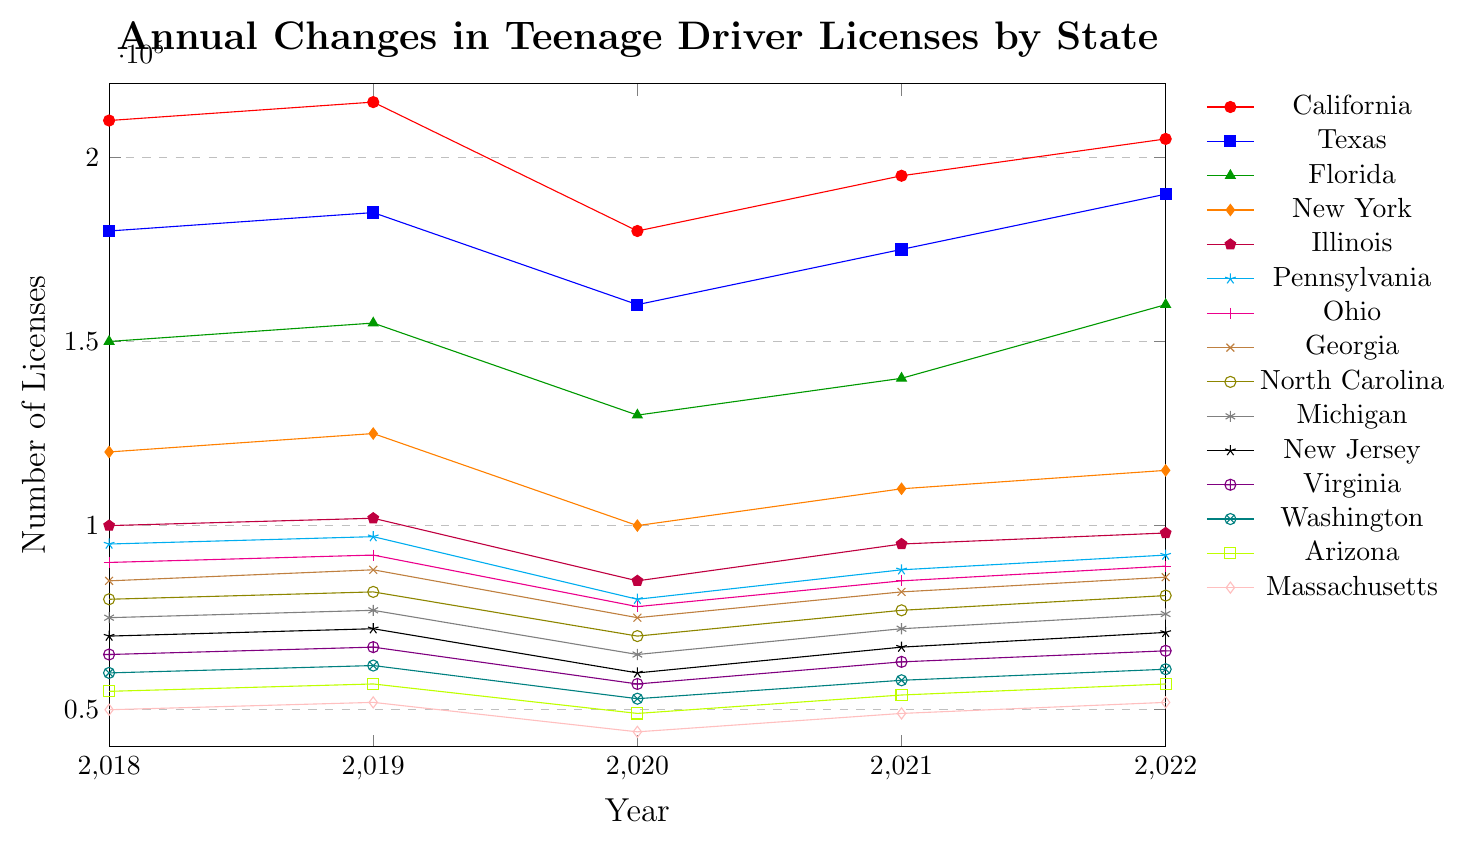Which state had the most teenage drivers obtaining licenses in 2020? The chart shows the number of teenage drivers obtaining licenses for each state across different years. For 2020, the highest value is for California with 180,000 licenses.
Answer: California Which state experienced the largest decrease in the number of teenage drivers obtaining licenses from 2019 to 2020? To find the largest decrease, calculate the difference between 2019 and 2020 numbers for each state. California had a decrease from 215,000 to 180,000, which is the largest drop of 35,000.
Answer: California By how much did the number of teenage drivers obtaining licenses in Georgia change from 2018 to 2022? Look at Georgia's values for 2018 (85,000) and 2022 (86,000), then subtract the 2018 value from the 2022 value: 86,000 - 85,000 = 1,000.
Answer: 1,000 Which state had the least fluctuations in teenage driver licenses between 2018 and 2022? Compare the changes for each state over the years. Massachusetts shows small changes of 50,000 to 52,000, down to 44,000, then back to 49,000, and 52,000. These are relatively small changes compared to other states.
Answer: Massachusetts Which states had their highest number of teenage drivers obtaining licenses in 2022? For each state, identify the year with the highest number. California's highest is in 2019, while Texas, and Florida have their peaks in 2022 with 190,000 and 160,000 respectively.
Answer: Texas, Florida What was the average number of teenage drivers obtaining licenses in Michigan from 2018 to 2022? Calculate the average of Michigan's numbers: (75,000 + 77,000 + 65,000 + 72,000 + 76,000)/5 = 73,000.
Answer: 73,000 Which states showed a consistent increase in the number of teenage drivers obtaining licenses from 2020 to 2022? Find states where each subsequent year from 2020 to 2022 shows an increase. Texas (160,000, 175,000, 190,000) and Florida (130,000, 140,000, 160,000) show consistent increases in teenage driver numbers.
Answer: Texas, Florida 